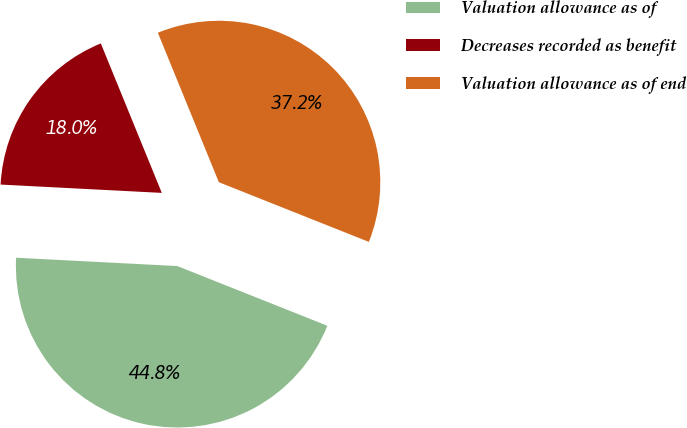Convert chart to OTSL. <chart><loc_0><loc_0><loc_500><loc_500><pie_chart><fcel>Valuation allowance as of<fcel>Decreases recorded as benefit<fcel>Valuation allowance as of end<nl><fcel>44.79%<fcel>18.01%<fcel>37.19%<nl></chart> 